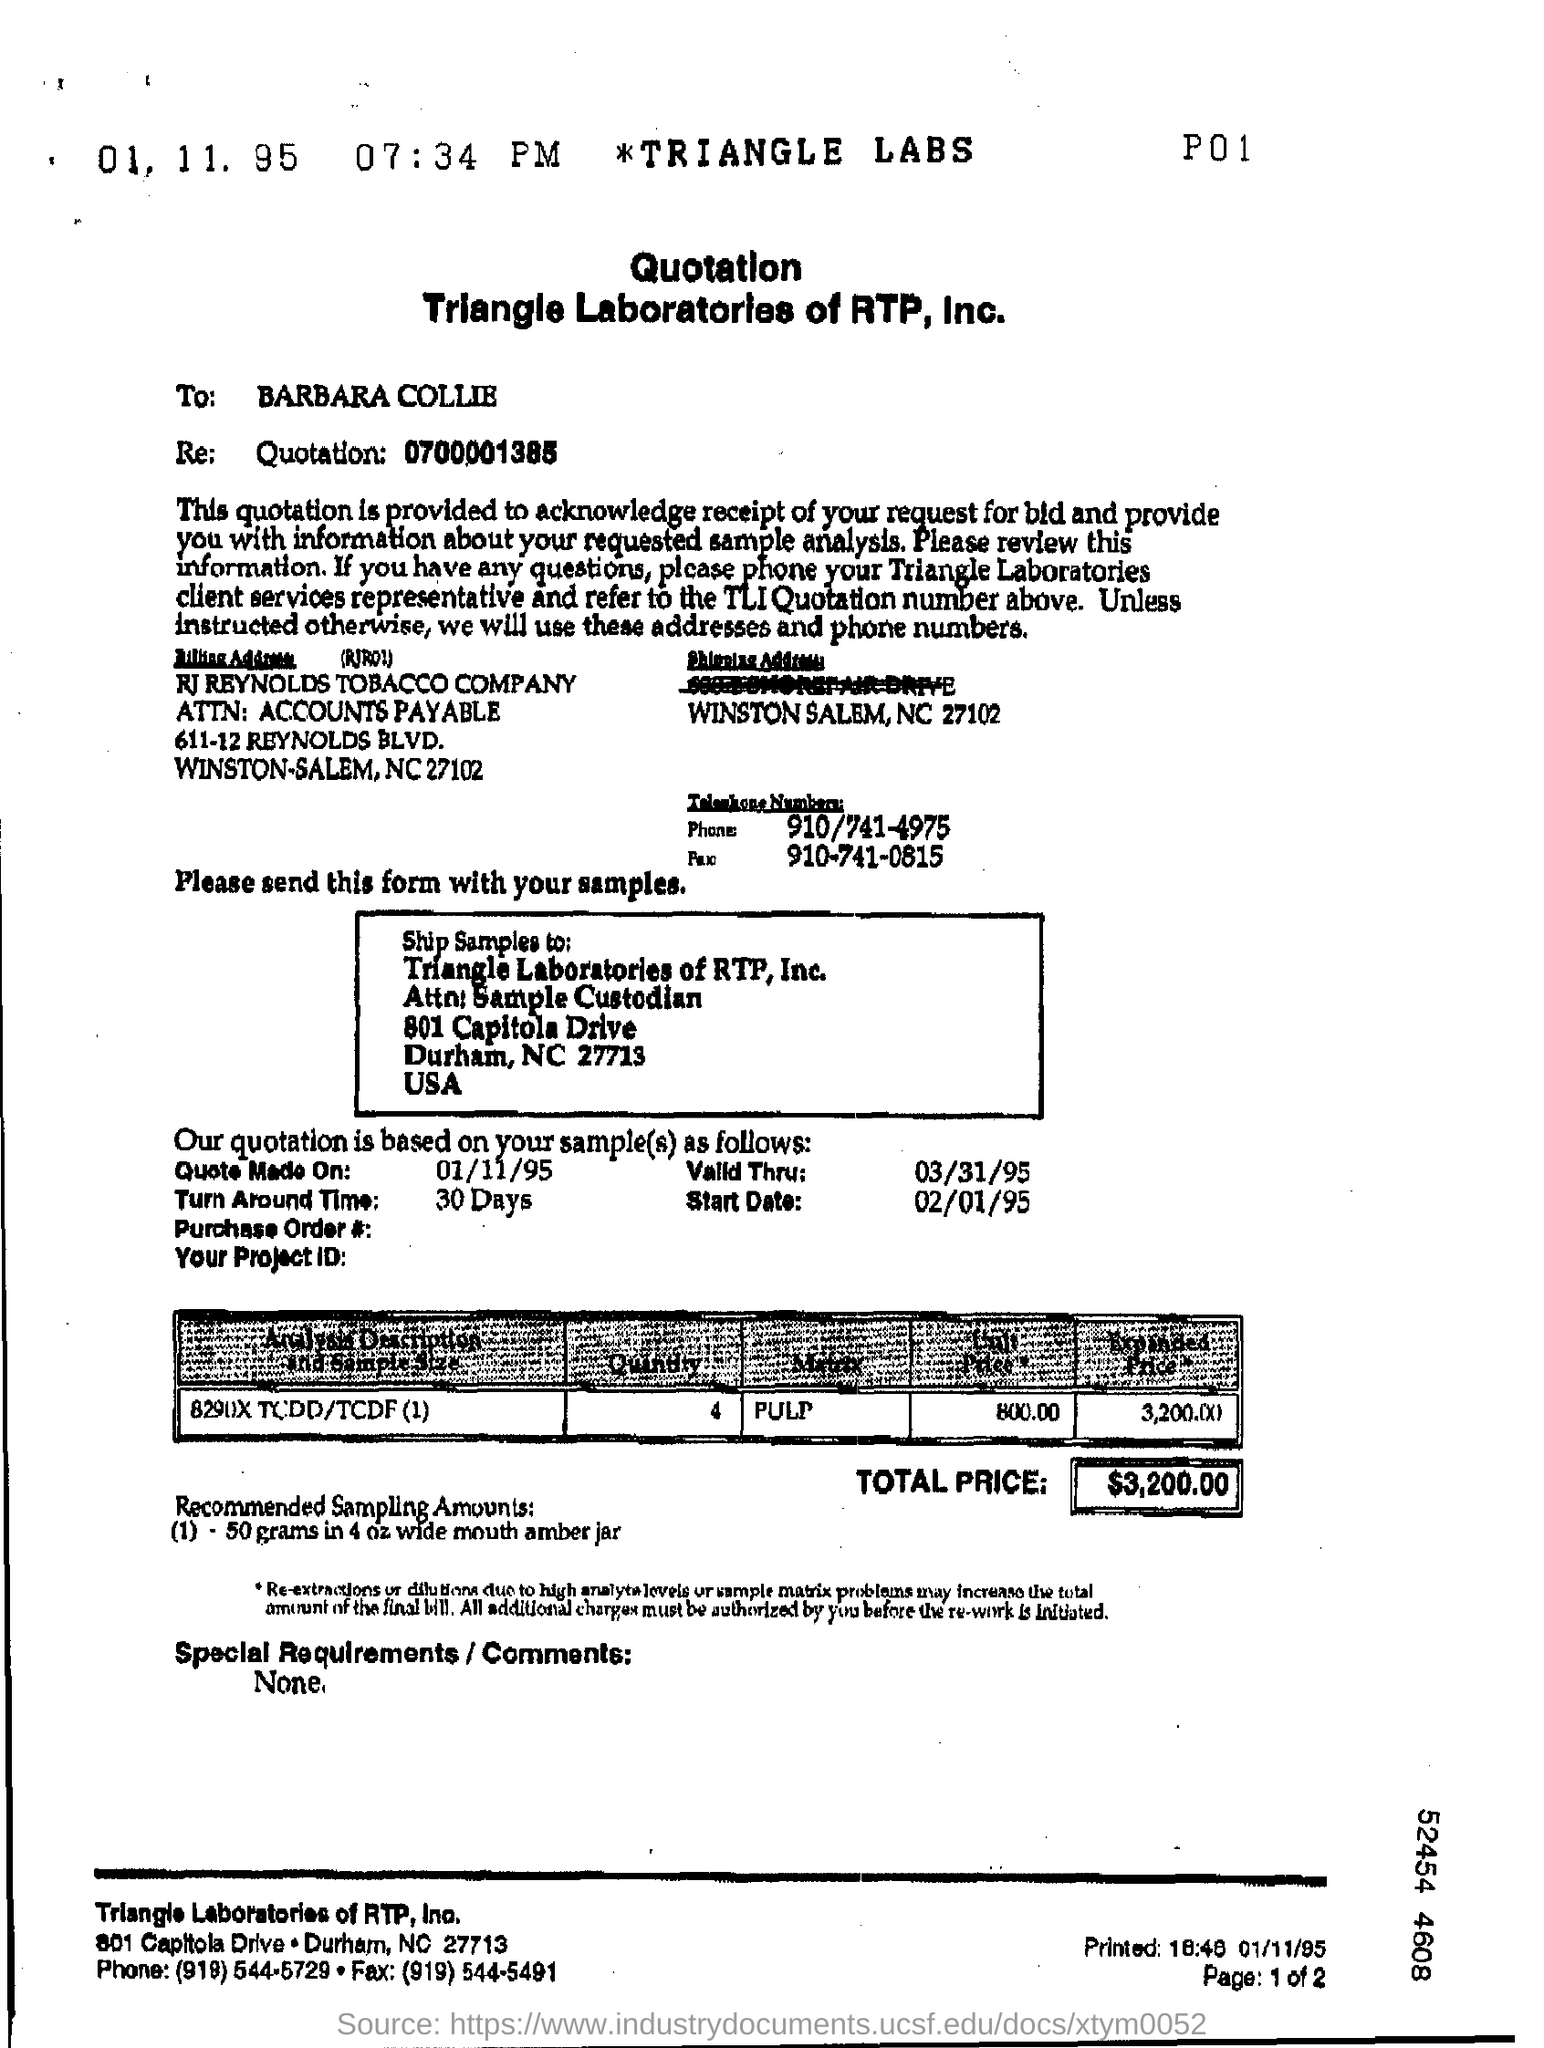What is the Recommended Sampling Amounts mentioned in this form?
Offer a very short reply. 50 grams in 4 oz wide mouth amber jar. 